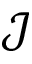Convert formula to latex. <formula><loc_0><loc_0><loc_500><loc_500>\mathcal { J }</formula> 